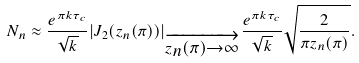<formula> <loc_0><loc_0><loc_500><loc_500>N _ { n } \approx \frac { e ^ { \pi k \tau _ { c } } } { \sqrt { k } } | J _ { 2 } ( z _ { n } ( \pi ) ) | _ { \overrightarrow { _ { z _ { n } ( \pi ) \rightarrow \infty } } } \frac { e ^ { \pi k \tau _ { c } } } { \sqrt { k } } \sqrt { \frac { 2 } { \pi z _ { n } ( \pi ) } } .</formula> 